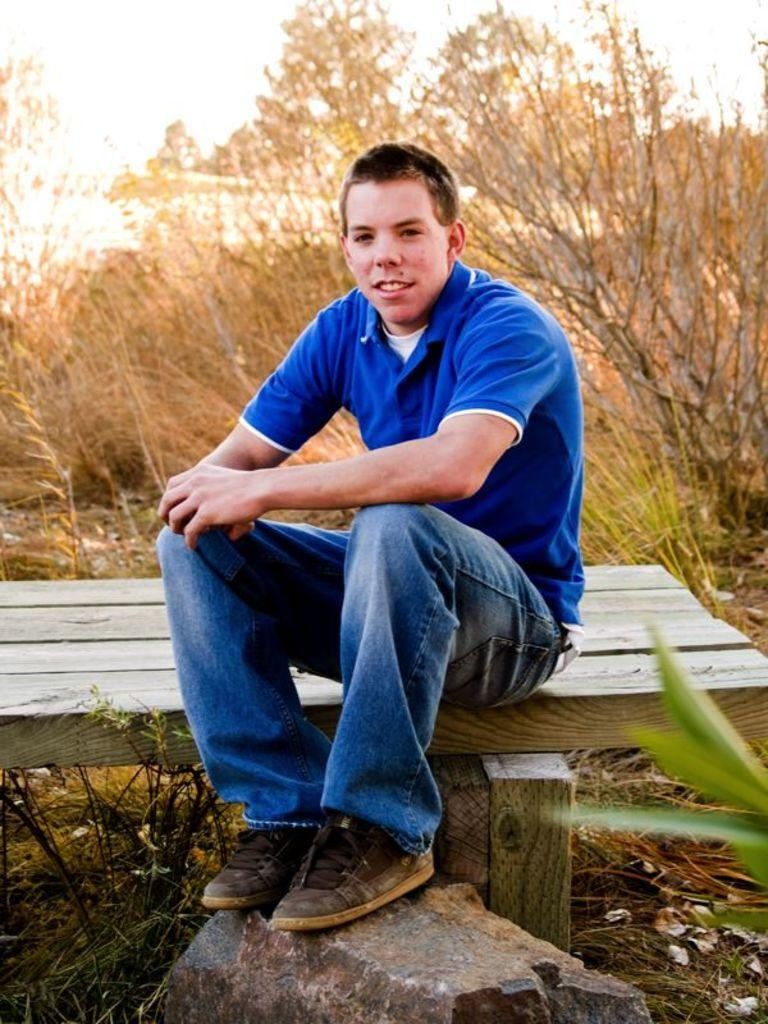Who is in the image? There is a man in the image. What is the man doing in the image? The man is sitting on a bench. What is the man's position in relation to the stone? The man has his feet on a stone. What can be seen in the background of the image? There are trees and the sky visible in the background of the image. What type of pin is the man using to hold his hat in the image? There is no pin visible in the image, and the man is not wearing a hat. 